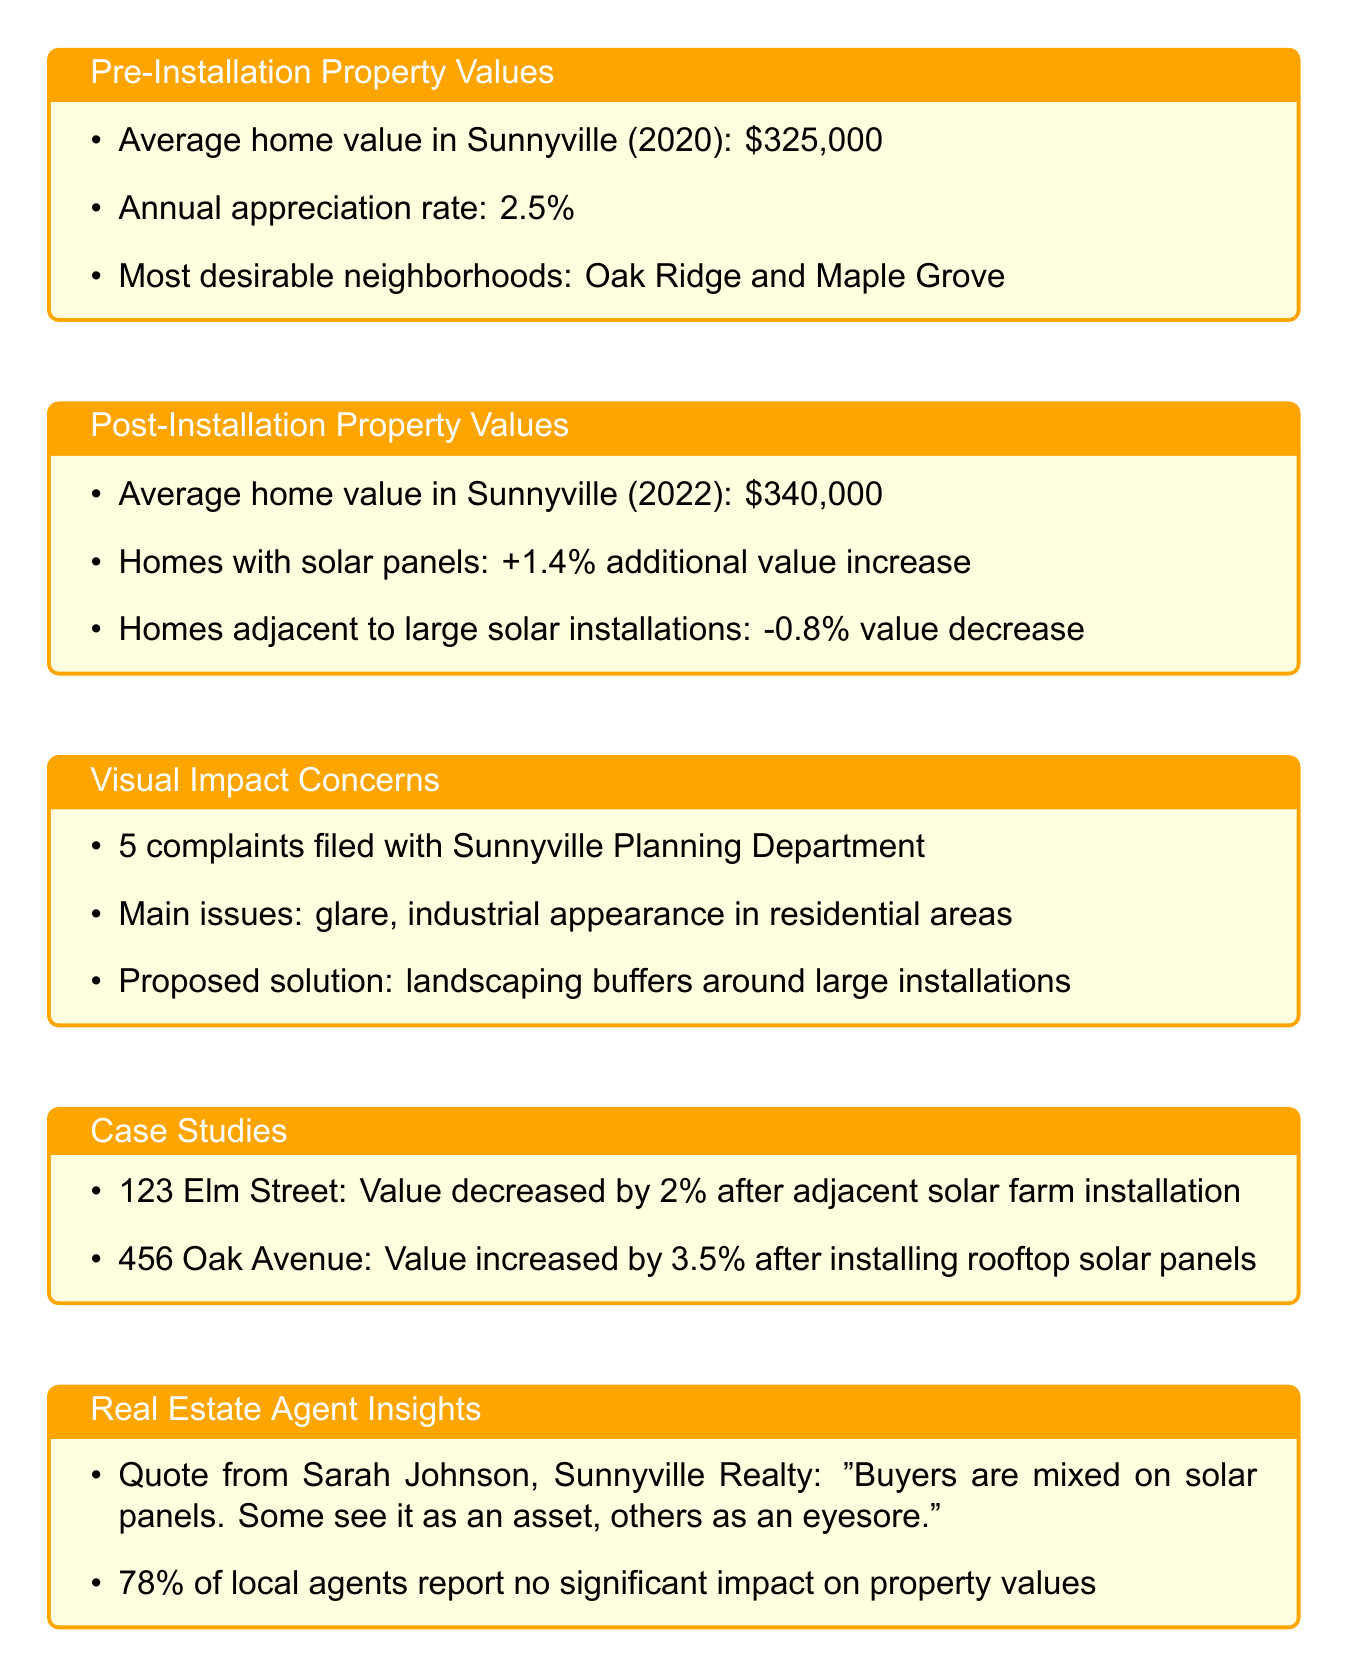What was the average home value in Sunnyville in 2020? The document states that the average home value in Sunnyville (2020) was $325,000.
Answer: $325,000 What is the annual appreciation rate mentioned? The document notes an annual appreciation rate of 2.5%.
Answer: 2.5% What is the percentage increase in value for homes with solar panels? According to the document, homes with solar panels experience a 1.4% additional value increase.
Answer: 1.4% How many complaints were filed with the Sunnyville Planning Department? The document mentions that there were 5 complaints filed.
Answer: 5 What percentage of local agents report no significant impact on property values? The document states that 78% of local agents report no significant impact on property values.
Answer: 78% What was the value change of the home at 123 Elm Street after the solar farm installation? The document indicates that the value decreased by 2%.
Answer: 2% What main issues were reported about the visual impact of solar panels? As per the document, the main issues were glare and industrial appearance in residential areas.
Answer: glare, industrial appearance What solution is proposed for visual impact concerns? The document suggests landscaping buffers around large installations as a proposed solution.
Answer: landscaping buffers How much did the value increase for the home at 456 Oak Avenue with rooftop solar panels? The document states that the value increased by 3.5% after installing rooftop solar panels.
Answer: 3.5% 